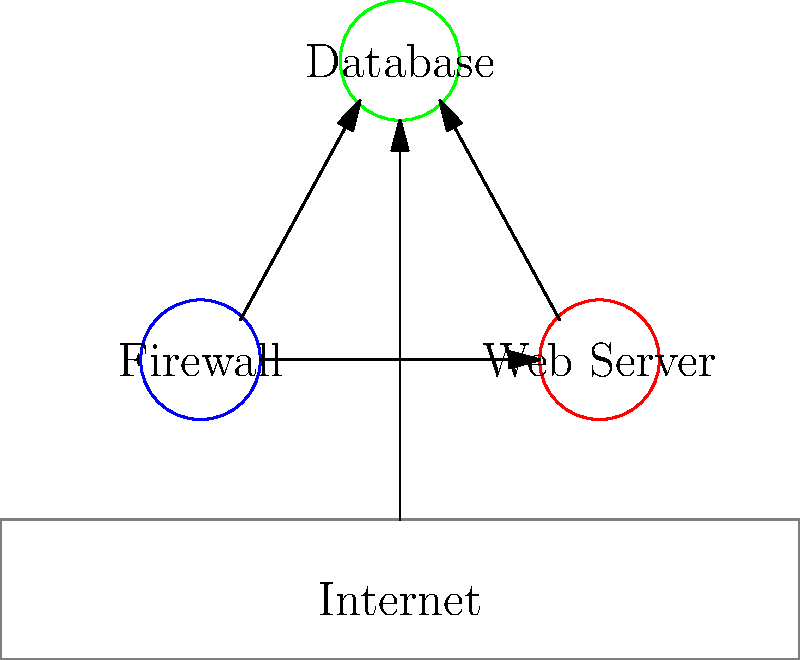Analisando o diagrama de arquitetura de sistema fornecido, identifique a vulnerabilidade de segurança mais crítica e explique por que ela representa um risco significativo. Para identificar a vulnerabilidade de segurança mais crítica neste diagrama, vamos analisar passo a passo:

1. Componentes do sistema:
   - Firewall
   - Servidor Web
   - Banco de Dados
   - Internet

2. Conexões:
   - Internet -> Firewall
   - Firewall -> Servidor Web
   - Servidor Web -> Banco de Dados
   - Internet -> Servidor Web (conexão direta)

3. Análise das vulnerabilidades:
   a) O firewall está posicionado corretamente entre a Internet e o servidor web.
   b) Há uma conexão adequada entre o servidor web e o banco de dados.
   c) A vulnerabilidade crítica é a conexão direta entre a Internet e o servidor web, ignorando o firewall.

4. Impacto da vulnerabilidade:
   - Permite acesso direto da Internet ao servidor web, contornando as proteções do firewall.
   - Expõe o servidor web a ataques diretos, como DDoS, injeção SQL, XSS, etc.
   - Aumenta o risco de comprometimento do servidor web e, potencialmente, do banco de dados.

5. Consequências:
   - Violação de dados
   - Interrupção de serviços
   - Comprometimento da integridade do sistema

Portanto, a vulnerabilidade mais crítica é a conexão direta entre a Internet e o servidor web, que ignora o firewall e compromete significativamente a segurança do sistema.
Answer: Conexão direta Internet-Servidor Web ignorando firewall 